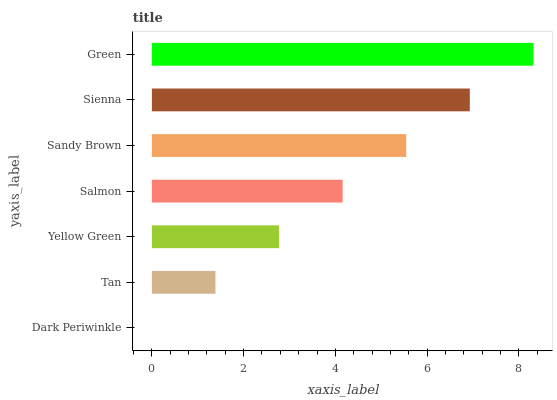Is Dark Periwinkle the minimum?
Answer yes or no. Yes. Is Green the maximum?
Answer yes or no. Yes. Is Tan the minimum?
Answer yes or no. No. Is Tan the maximum?
Answer yes or no. No. Is Tan greater than Dark Periwinkle?
Answer yes or no. Yes. Is Dark Periwinkle less than Tan?
Answer yes or no. Yes. Is Dark Periwinkle greater than Tan?
Answer yes or no. No. Is Tan less than Dark Periwinkle?
Answer yes or no. No. Is Salmon the high median?
Answer yes or no. Yes. Is Salmon the low median?
Answer yes or no. Yes. Is Dark Periwinkle the high median?
Answer yes or no. No. Is Sienna the low median?
Answer yes or no. No. 